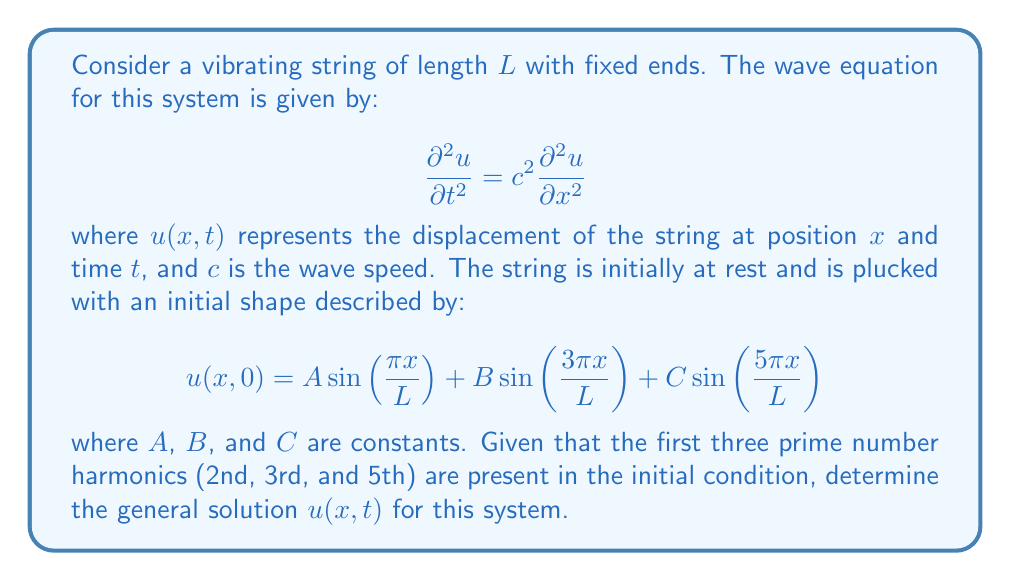Can you solve this math problem? To solve this problem, we'll follow these steps:

1) The general solution for the wave equation with fixed ends is given by:

   $$u(x,t) = \sum_{n=1}^{\infty} [a_n \cos(\frac{n\pi c t}{L}) + b_n \sin(\frac{n\pi c t}{L})] \sin(\frac{n\pi x}{L})$$

2) Given the initial condition, we can see that only the 2nd, 3rd, and 5th harmonics are present. Therefore, we can simplify our solution to:

   $$u(x,t) = [a_2 \cos(\frac{2\pi c t}{L}) + b_2 \sin(\frac{2\pi c t}{L})] \sin(\frac{2\pi x}{L}) + \\
              [a_3 \cos(\frac{3\pi c t}{L}) + b_3 \sin(\frac{3\pi c t}{L})] \sin(\frac{3\pi x}{L}) + \\
              [a_5 \cos(\frac{5\pi c t}{L}) + b_5 \sin(\frac{5\pi c t}{L})] \sin(\frac{5\pi x}{L})$$

3) At $t=0$, the string is at rest, which means $\frac{\partial u}{\partial t}(x,0) = 0$. This implies that all $b_n = 0$.

4) Comparing the initial condition with our solution at $t=0$:

   $$A \sin(\frac{\pi x}{L}) + B \sin(\frac{3\pi x}{L}) + C \sin(\frac{5\pi x}{L}) = \\
     a_2 \sin(\frac{2\pi x}{L}) + a_3 \sin(\frac{3\pi x}{L}) + a_5 \sin(\frac{5\pi x}{L})$$

5) We can identify that $a_2 = A$, $a_3 = B$, and $a_5 = C$.

6) Therefore, the general solution is:

   $$u(x,t) = A \cos(\frac{2\pi c t}{L}) \sin(\frac{2\pi x}{L}) + \\
              B \cos(\frac{3\pi c t}{L}) \sin(\frac{3\pi x}{L}) + \\
              C \cos(\frac{5\pi c t}{L}) \sin(\frac{5\pi x}{L})$$

This solution represents a superposition of standing waves with frequencies corresponding to the 2nd, 3rd, and 5th harmonics, which are all prime number harmonics.
Answer: $$u(x,t) = A \cos(\frac{2\pi c t}{L}) \sin(\frac{2\pi x}{L}) + B \cos(\frac{3\pi c t}{L}) \sin(\frac{3\pi x}{L}) + C \cos(\frac{5\pi c t}{L}) \sin(\frac{5\pi x}{L})$$ 